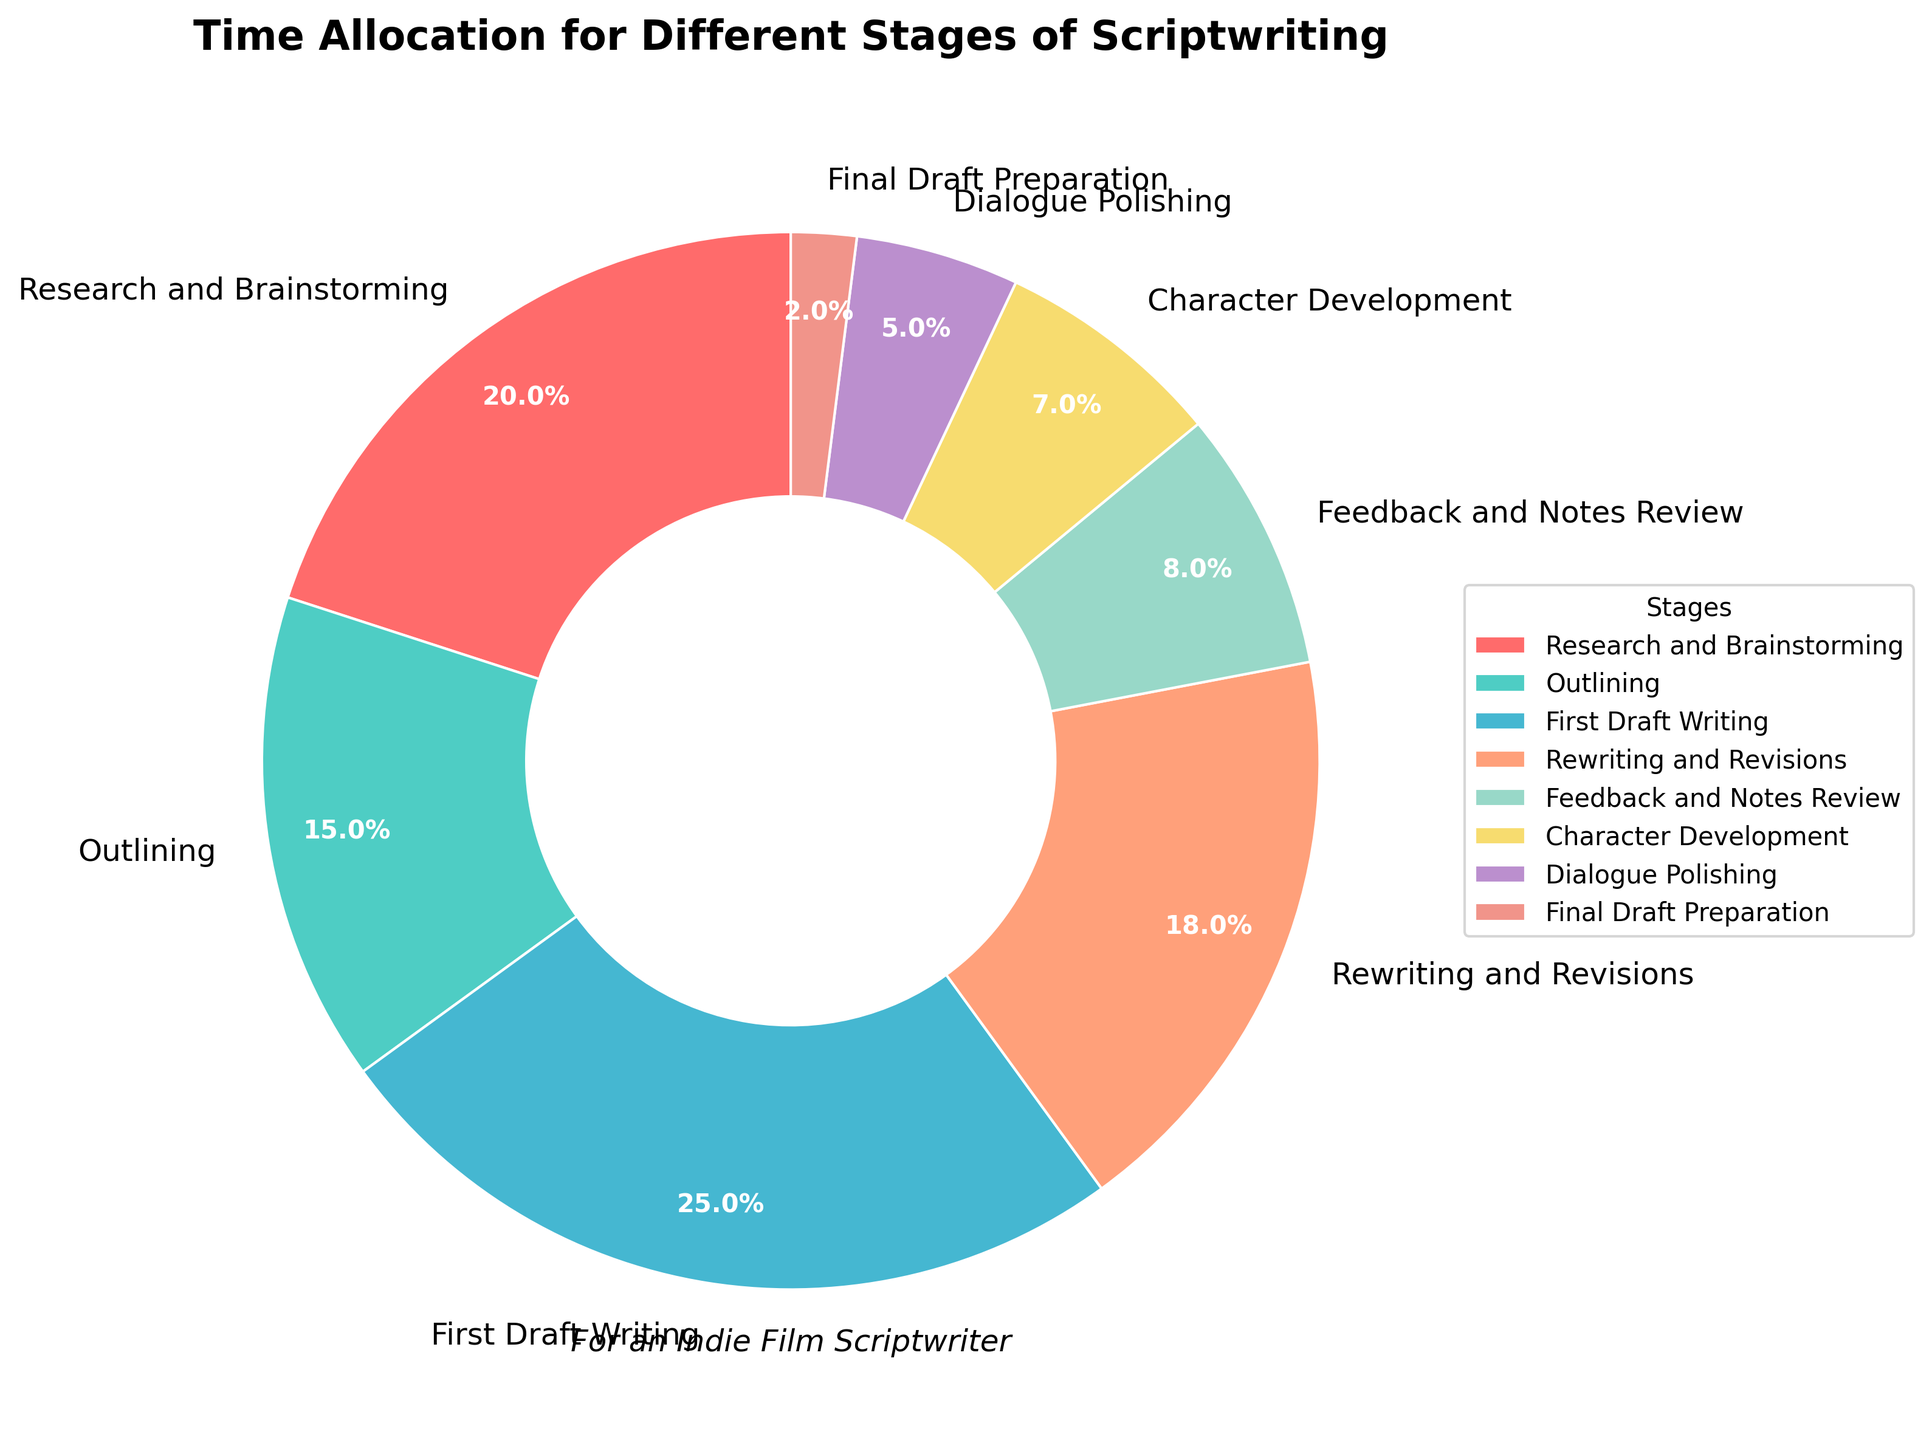What stage takes up the largest percentage of time in scriptwriting? Look at the section that is visually largest on the pie chart, which corresponds to the highest percentage.
Answer: First Draft Writing What is the combined percentage of time spent on Research and Brainstorming and Outlining? Add the percentages for Research and Brainstorming (20%) and Outlining (15%).
Answer: 35% Which stage takes up a smaller percentage of time, Dialogue Polishing, or Character Development? Compare the percentage for Dialogue Polishing (5%) with Character Development (7%).
Answer: Dialogue Polishing How much more time is allocated to Rewriting and Revisions compared to Feedback and Notes Review? Subtract the percentage of Feedback and Notes Review (8%) from Rewriting and Revisions (18%).
Answer: 10% Which stages together make up less than 10% of the total time allocated? Identify the percentages for Final Draft Preparation (2%) and Dialogue Polishing (5%), then check if their individual values are under 10%.
Answer: Final Draft Preparation, Dialogue Polishing How much total time is allocated to First Draft Writing, Rewriting and Revisions, and Feedback and Notes Review? Sum the percentages for First Draft Writing (25%), Rewriting and Revisions (18%), and Feedback and Notes Review (8%).
Answer: 51% Which color represents the stage with the smallest percentage of time allocated? Identify the color associated with Final Draft Preparation (2%). The colors can be identified in the visualization by their visual attributes.
Answer: (The concise answer should mention the color, but this may vary based on the precise implementation or visual observation — e.g., "light yellow" if that's visually evident on the chart.) What is the percentage difference between Research and Brainstorming and Outlining? Subtract the percentage of Outlining (15%) from Research and Brainstorming (20%).
Answer: 5% If you combine Dialogue Polishing and Final Draft Preparation, what is their total contribution in percentage? Add the percentages of Dialogue Polishing (5%) and Final Draft Preparation (2%).
Answer: 7% Which stage has a percentage close to the average of all the stages' percentages? First, calculate the average percentage: (20 + 15 + 25 + 18 + 8 + 7 + 5 + 2)/8 = 100/8 = 12.5%. Identify the stage closest to this average.
Answer: Feedback and Notes Review 